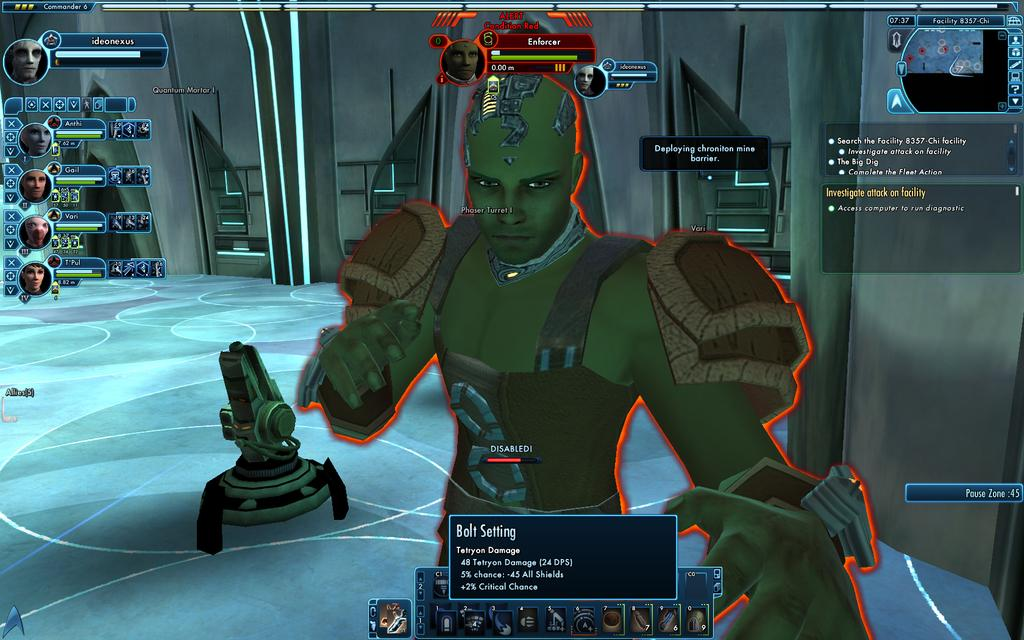What type of image is depicted in the picture? There is an animated picture of a person in the image. What else can be seen in the image besides the animated person? There is text visible in the image. Where is the mitten located in the image? There is no mitten present in the image. What event is taking place in the image related to a birth? There is no event related to a birth depicted in the image. 